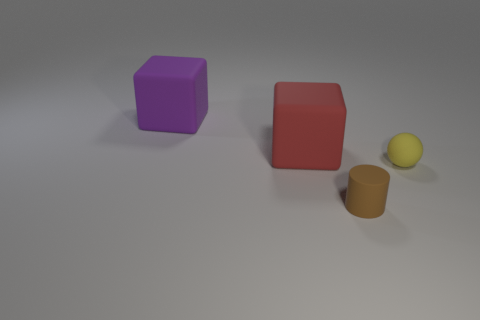Does the big object to the right of the large purple matte block have the same material as the yellow thing?
Your answer should be very brief. Yes. Is the material of the big cube that is on the left side of the large red thing the same as the large block that is in front of the purple matte cube?
Provide a succinct answer. Yes. Is the number of yellow rubber spheres in front of the red thing greater than the number of tiny purple matte cylinders?
Keep it short and to the point. Yes. There is a matte ball to the right of the object that is to the left of the red rubber cube; what color is it?
Your answer should be very brief. Yellow. There is a brown matte thing that is the same size as the yellow sphere; what is its shape?
Your answer should be compact. Cylinder. Are there the same number of large objects to the right of the red thing and big gray things?
Provide a succinct answer. Yes. There is a big purple thing that is the same material as the large red object; what is its shape?
Keep it short and to the point. Cube. How many brown matte cylinders are in front of the matte block that is on the right side of the rubber object that is behind the red object?
Your response must be concise. 1. How many yellow things are matte cubes or rubber balls?
Your answer should be compact. 1. Does the purple object have the same size as the matte block to the right of the large purple block?
Your answer should be very brief. Yes. 